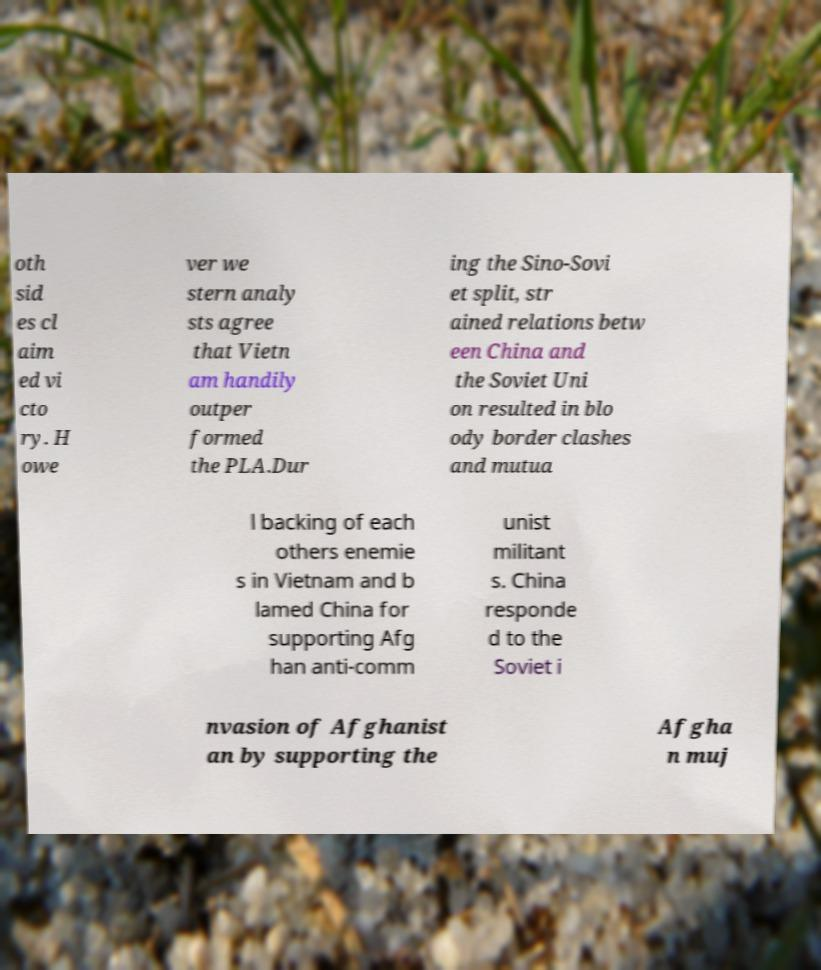Could you assist in decoding the text presented in this image and type it out clearly? oth sid es cl aim ed vi cto ry. H owe ver we stern analy sts agree that Vietn am handily outper formed the PLA.Dur ing the Sino-Sovi et split, str ained relations betw een China and the Soviet Uni on resulted in blo ody border clashes and mutua l backing of each others enemie s in Vietnam and b lamed China for supporting Afg han anti-comm unist militant s. China responde d to the Soviet i nvasion of Afghanist an by supporting the Afgha n muj 